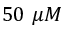Convert formula to latex. <formula><loc_0><loc_0><loc_500><loc_500>5 0 \mu M</formula> 